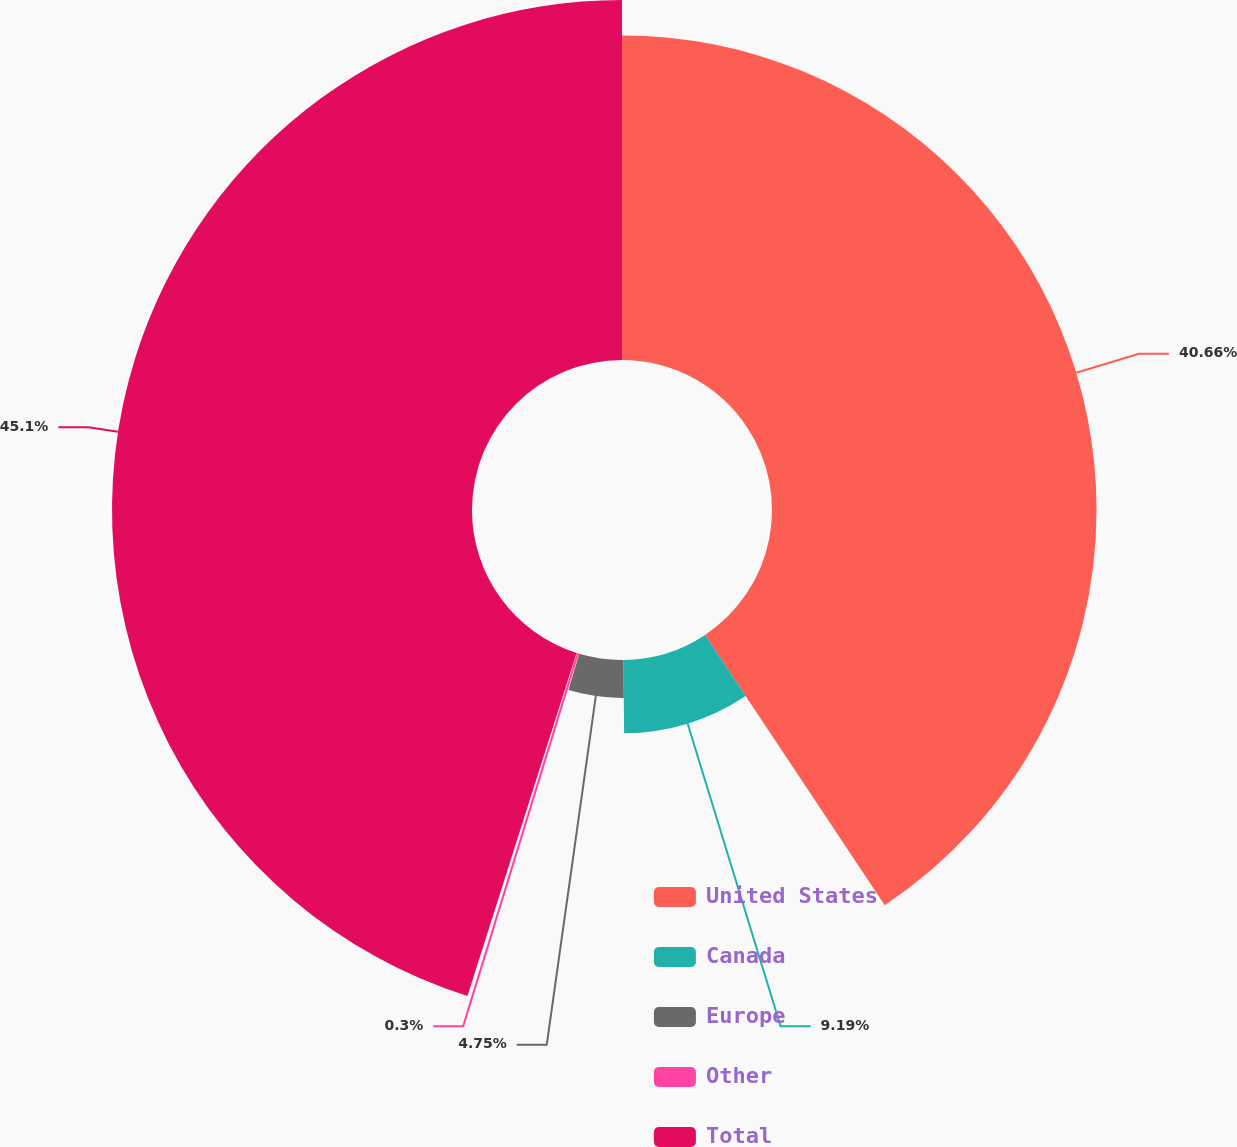<chart> <loc_0><loc_0><loc_500><loc_500><pie_chart><fcel>United States<fcel>Canada<fcel>Europe<fcel>Other<fcel>Total<nl><fcel>40.66%<fcel>9.19%<fcel>4.75%<fcel>0.3%<fcel>45.1%<nl></chart> 